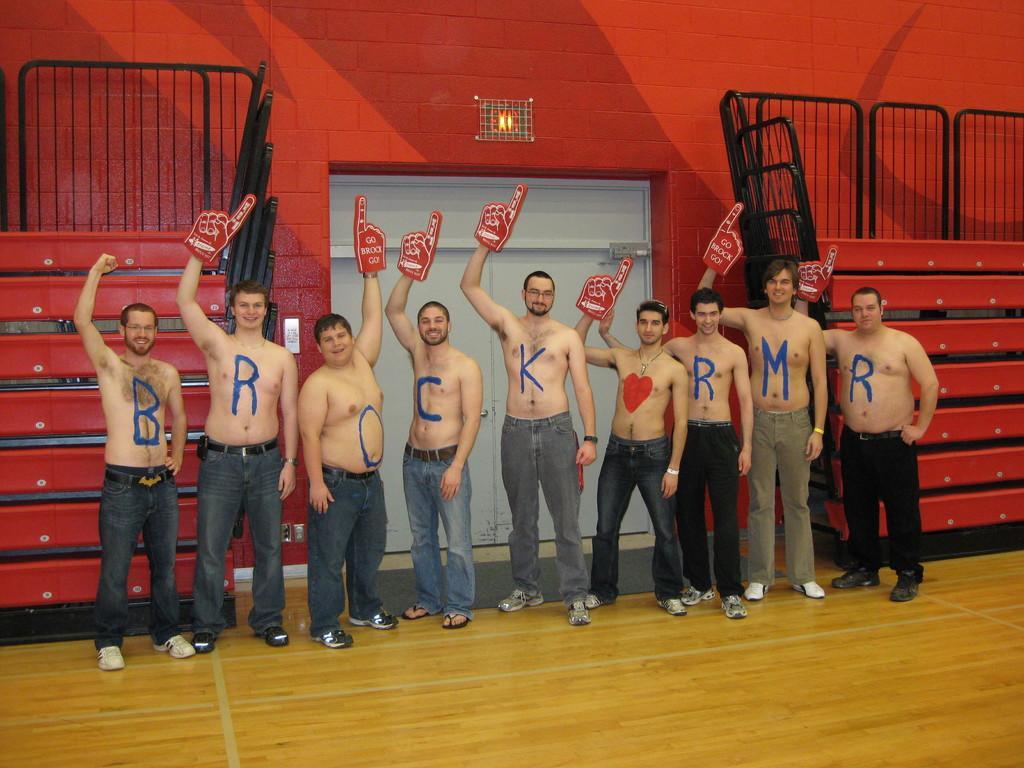Can you describe this image briefly? In this picture I can see few men standing with out shirts and I can see alphabets on their body and few of them holding hand symbol in their hands and I can see stairs on both sides of the door. Looks like a Indoor stadium and a light on the top of the door. 